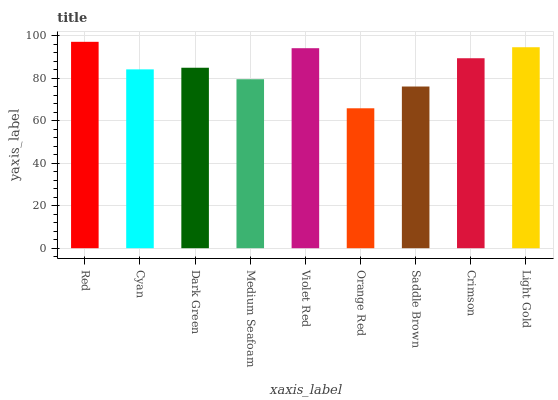Is Orange Red the minimum?
Answer yes or no. Yes. Is Red the maximum?
Answer yes or no. Yes. Is Cyan the minimum?
Answer yes or no. No. Is Cyan the maximum?
Answer yes or no. No. Is Red greater than Cyan?
Answer yes or no. Yes. Is Cyan less than Red?
Answer yes or no. Yes. Is Cyan greater than Red?
Answer yes or no. No. Is Red less than Cyan?
Answer yes or no. No. Is Dark Green the high median?
Answer yes or no. Yes. Is Dark Green the low median?
Answer yes or no. Yes. Is Violet Red the high median?
Answer yes or no. No. Is Light Gold the low median?
Answer yes or no. No. 